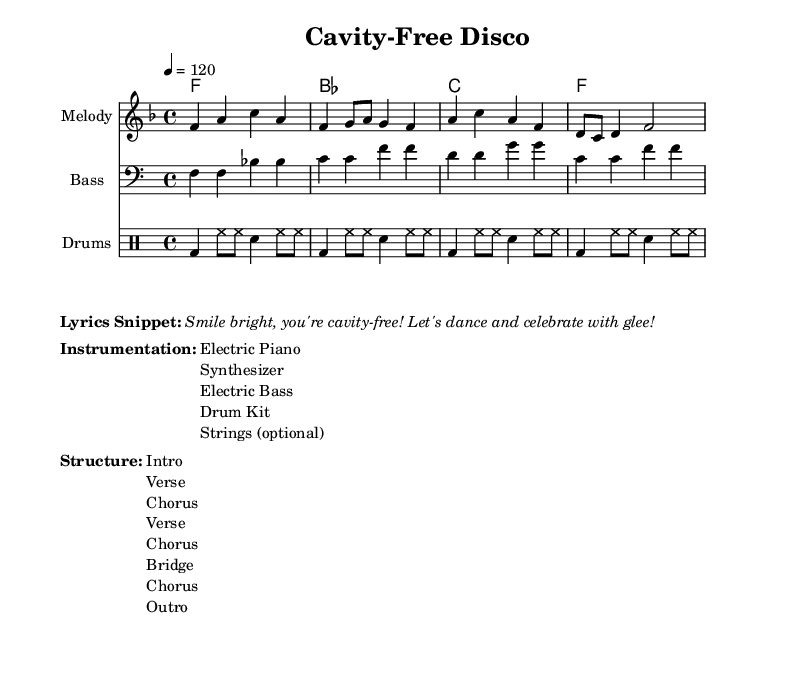What is the key signature of this music? The key signature is F major, which has one flat (B flat).
Answer: F major What is the time signature of this music? The time signature is 4/4, indicating there are four beats per measure.
Answer: 4/4 What is the tempo marking for this piece? The tempo marking is quarter note equals 120 beats per minute, indicating a moderate tempo suited for dance music.
Answer: 120 How many verses are included in the structure? The structure contains two verses as seen in the order provided before the repeated choruses.
Answer: 2 Which instrument is used for the melody? The melody is performed on the Electric Piano, which is noted in the instrumentation section.
Answer: Electric Piano What kind of rhythm do the drums play? The drums play a consistent beat with bass drums and hi-hats, designed to keep energy high throughout the piece as indicated in the drummode section.
Answer: Consistent beat What word describes the overall mood of the lyrics? The lyrics convey celebration and positivity around successful dental check-ups, reflecting a joyful and upbeat mood.
Answer: Joyful 